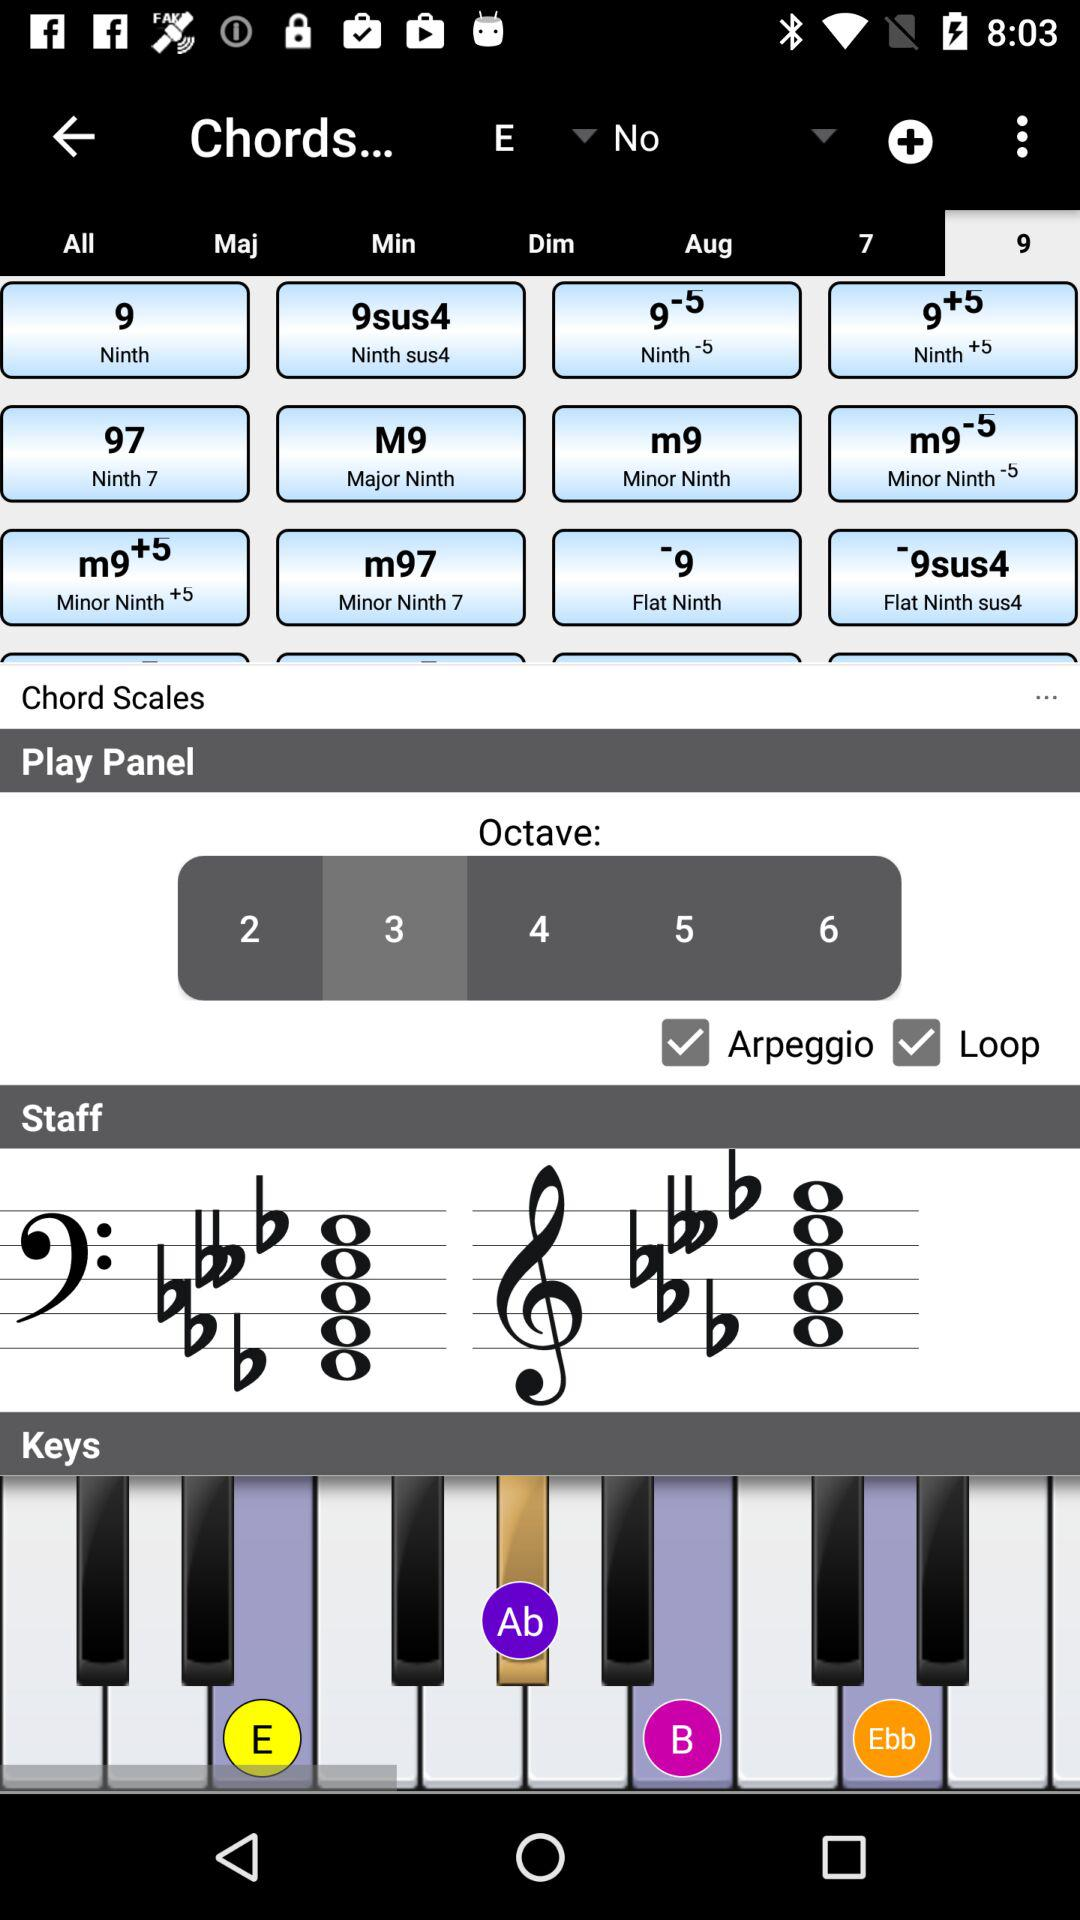What is the current status of the "Loop" setting in "Play Panel"? The current status of the "Loop" setting in "Play Panel" is "on". 